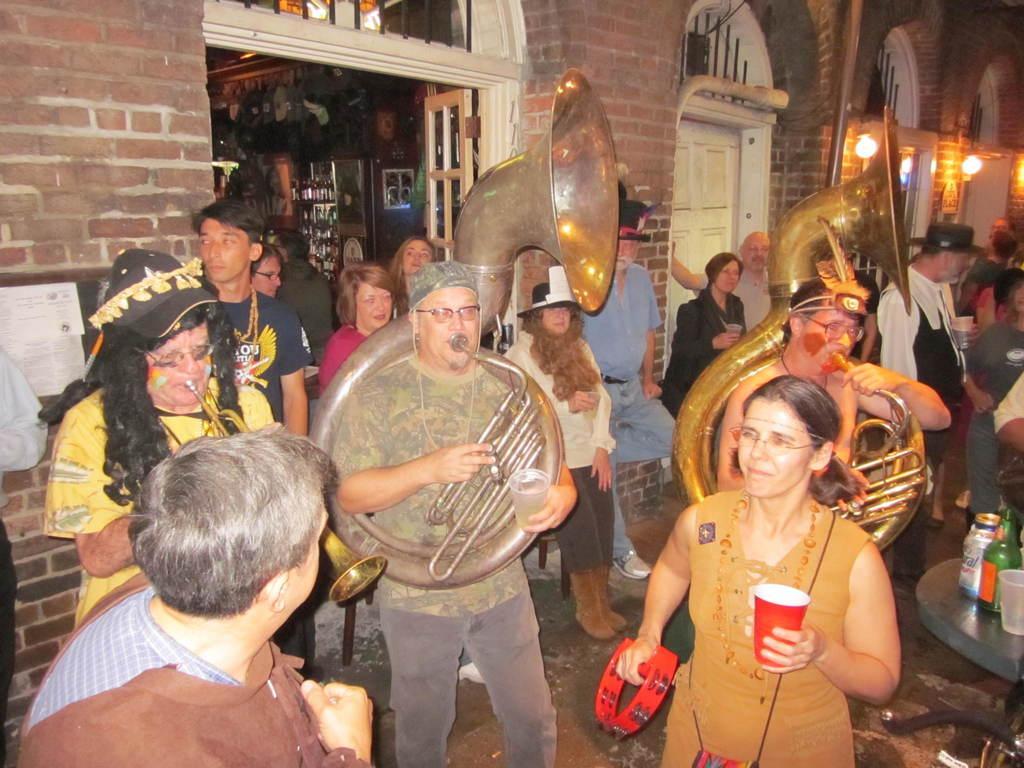In one or two sentences, can you explain what this image depicts? In this image we can see three people standing and playing a musical instruments and some of them are holding glasses in their hands. On the right there is a table and we can see bottles, tins and a glass placed on the table. In the background there are doors, walls and lights. 